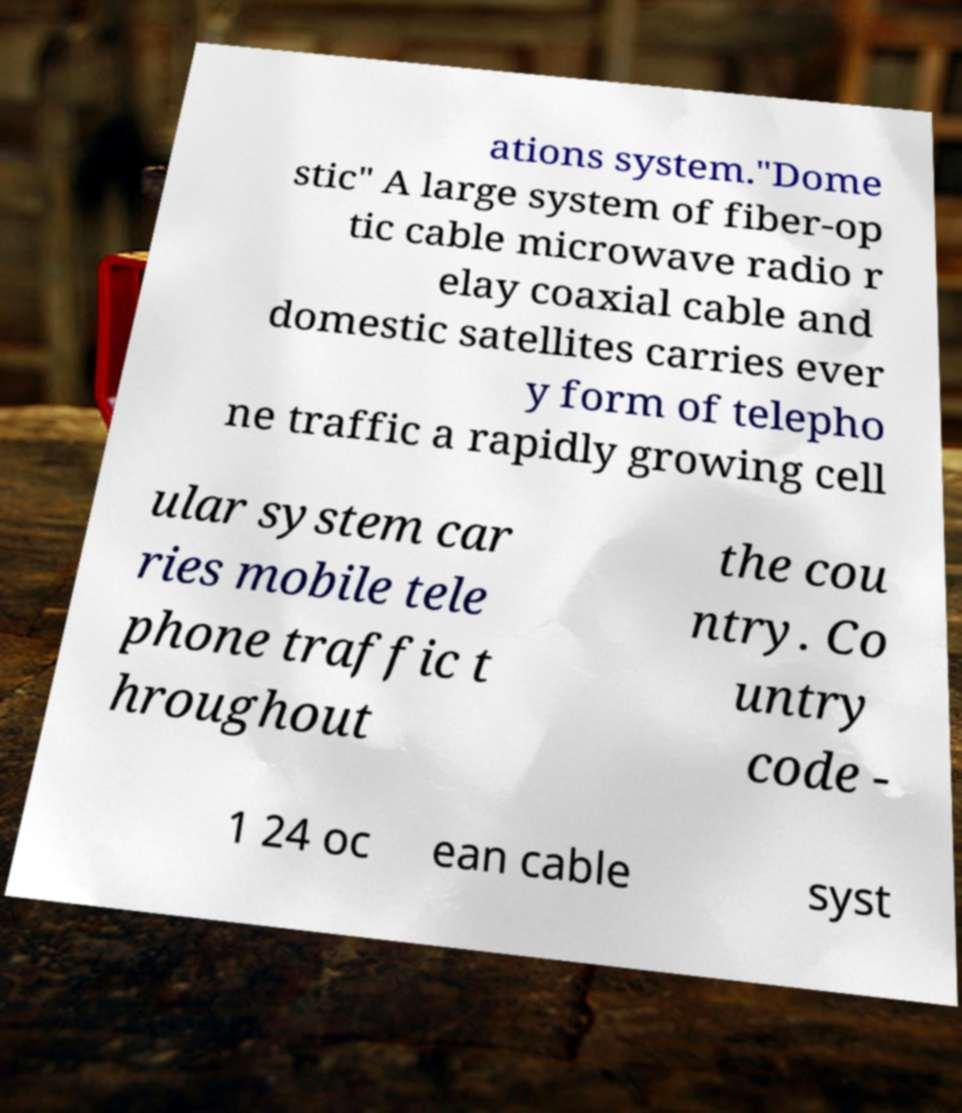For documentation purposes, I need the text within this image transcribed. Could you provide that? ations system."Dome stic" A large system of fiber-op tic cable microwave radio r elay coaxial cable and domestic satellites carries ever y form of telepho ne traffic a rapidly growing cell ular system car ries mobile tele phone traffic t hroughout the cou ntry. Co untry code - 1 24 oc ean cable syst 